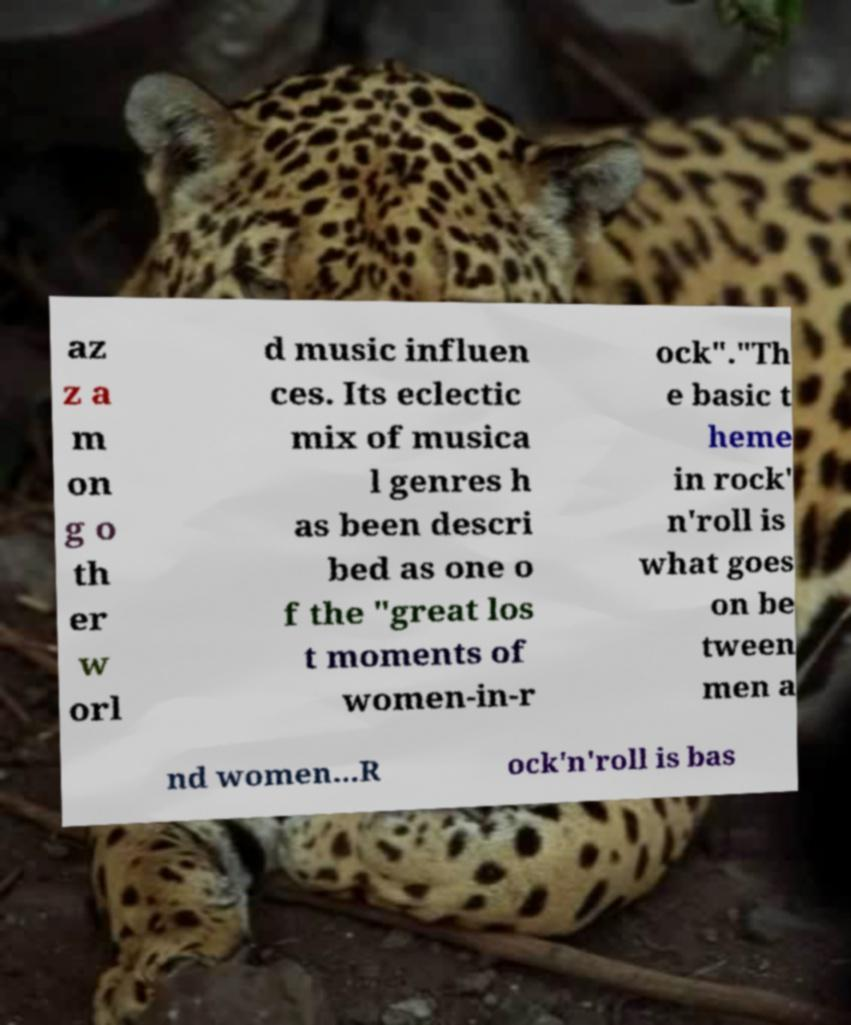Please identify and transcribe the text found in this image. az z a m on g o th er w orl d music influen ces. Its eclectic mix of musica l genres h as been descri bed as one o f the "great los t moments of women-in-r ock"."Th e basic t heme in rock' n'roll is what goes on be tween men a nd women...R ock'n'roll is bas 